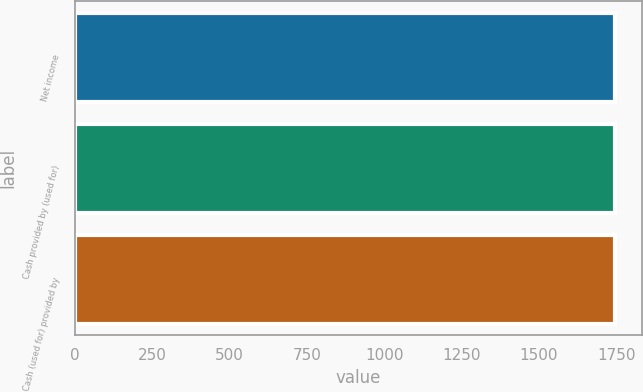Convert chart to OTSL. <chart><loc_0><loc_0><loc_500><loc_500><bar_chart><fcel>Net income<fcel>Cash provided by (used for)<fcel>Cash (used for) provided by<nl><fcel>1745<fcel>1745.1<fcel>1745.2<nl></chart> 